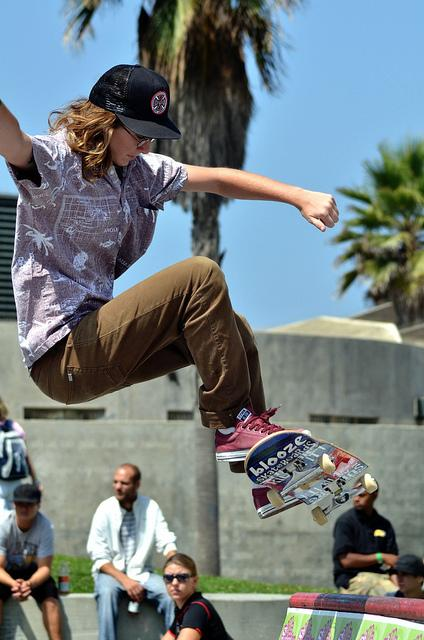In what style park does the skateboarder skate? Please explain your reasoning. skate park. The place is make for skateboards and skaters. 